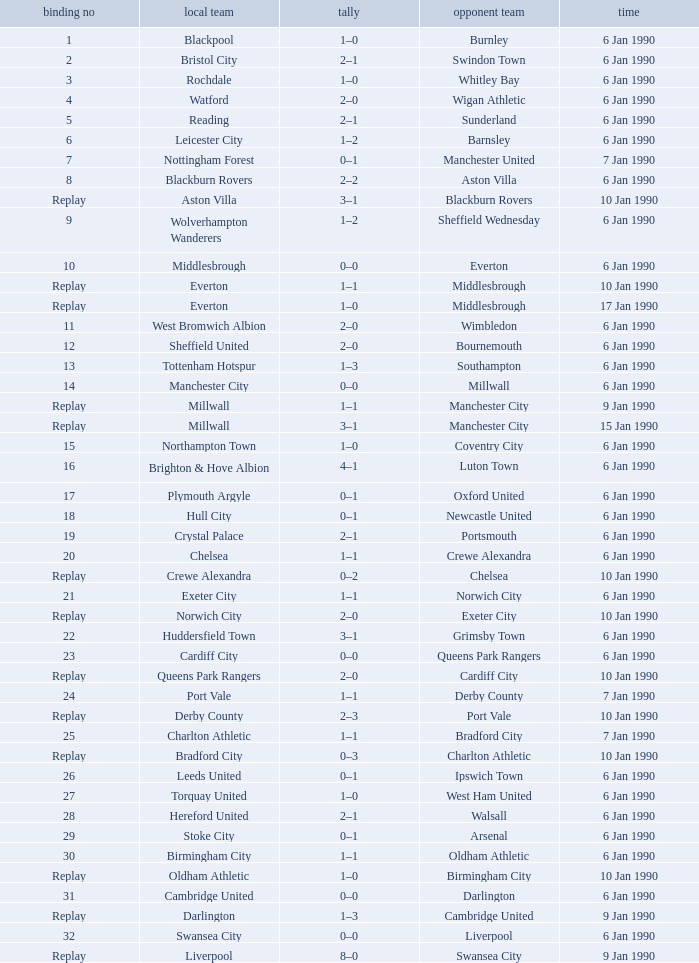What is the tie no of the game where exeter city was the home team? 21.0. 